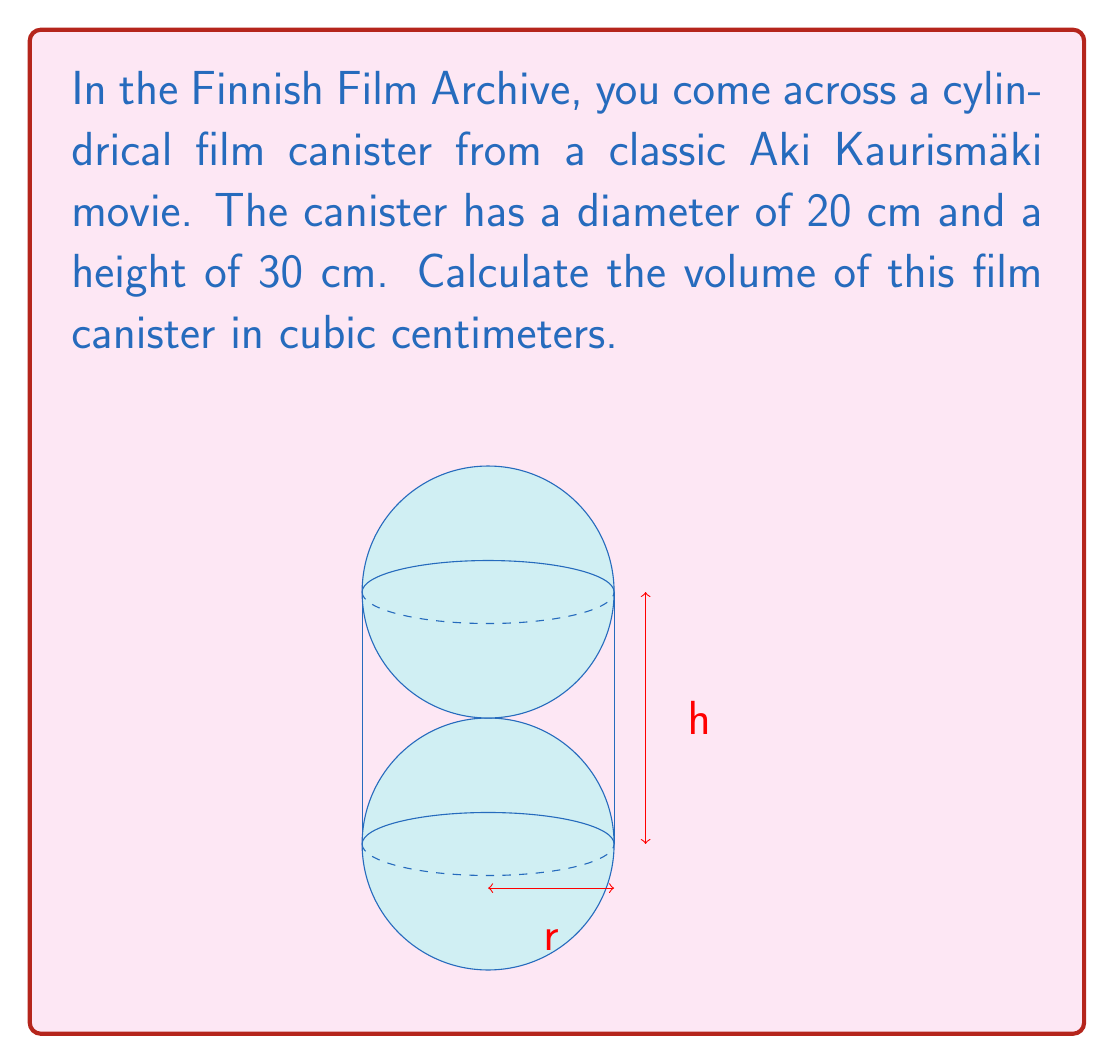Solve this math problem. To calculate the volume of a cylinder, we use the formula:

$$V = \pi r^2 h$$

Where:
$V$ = volume
$r$ = radius (half the diameter)
$h$ = height

Given:
- Diameter = 20 cm
- Height = 30 cm

Step 1: Calculate the radius
$$r = \frac{\text{diameter}}{2} = \frac{20 \text{ cm}}{2} = 10 \text{ cm}$$

Step 2: Substitute the values into the formula
$$V = \pi (10 \text{ cm})^2 (30 \text{ cm})$$

Step 3: Calculate
$$V = \pi (100 \text{ cm}^2) (30 \text{ cm})$$
$$V = 3000\pi \text{ cm}^3$$

Step 4: Evaluate $\pi$ (to 2 decimal places)
$$V \approx 3000 \times 3.14 \text{ cm}^3$$
$$V \approx 9420 \text{ cm}^3$$
Answer: $9420 \text{ cm}^3$ 